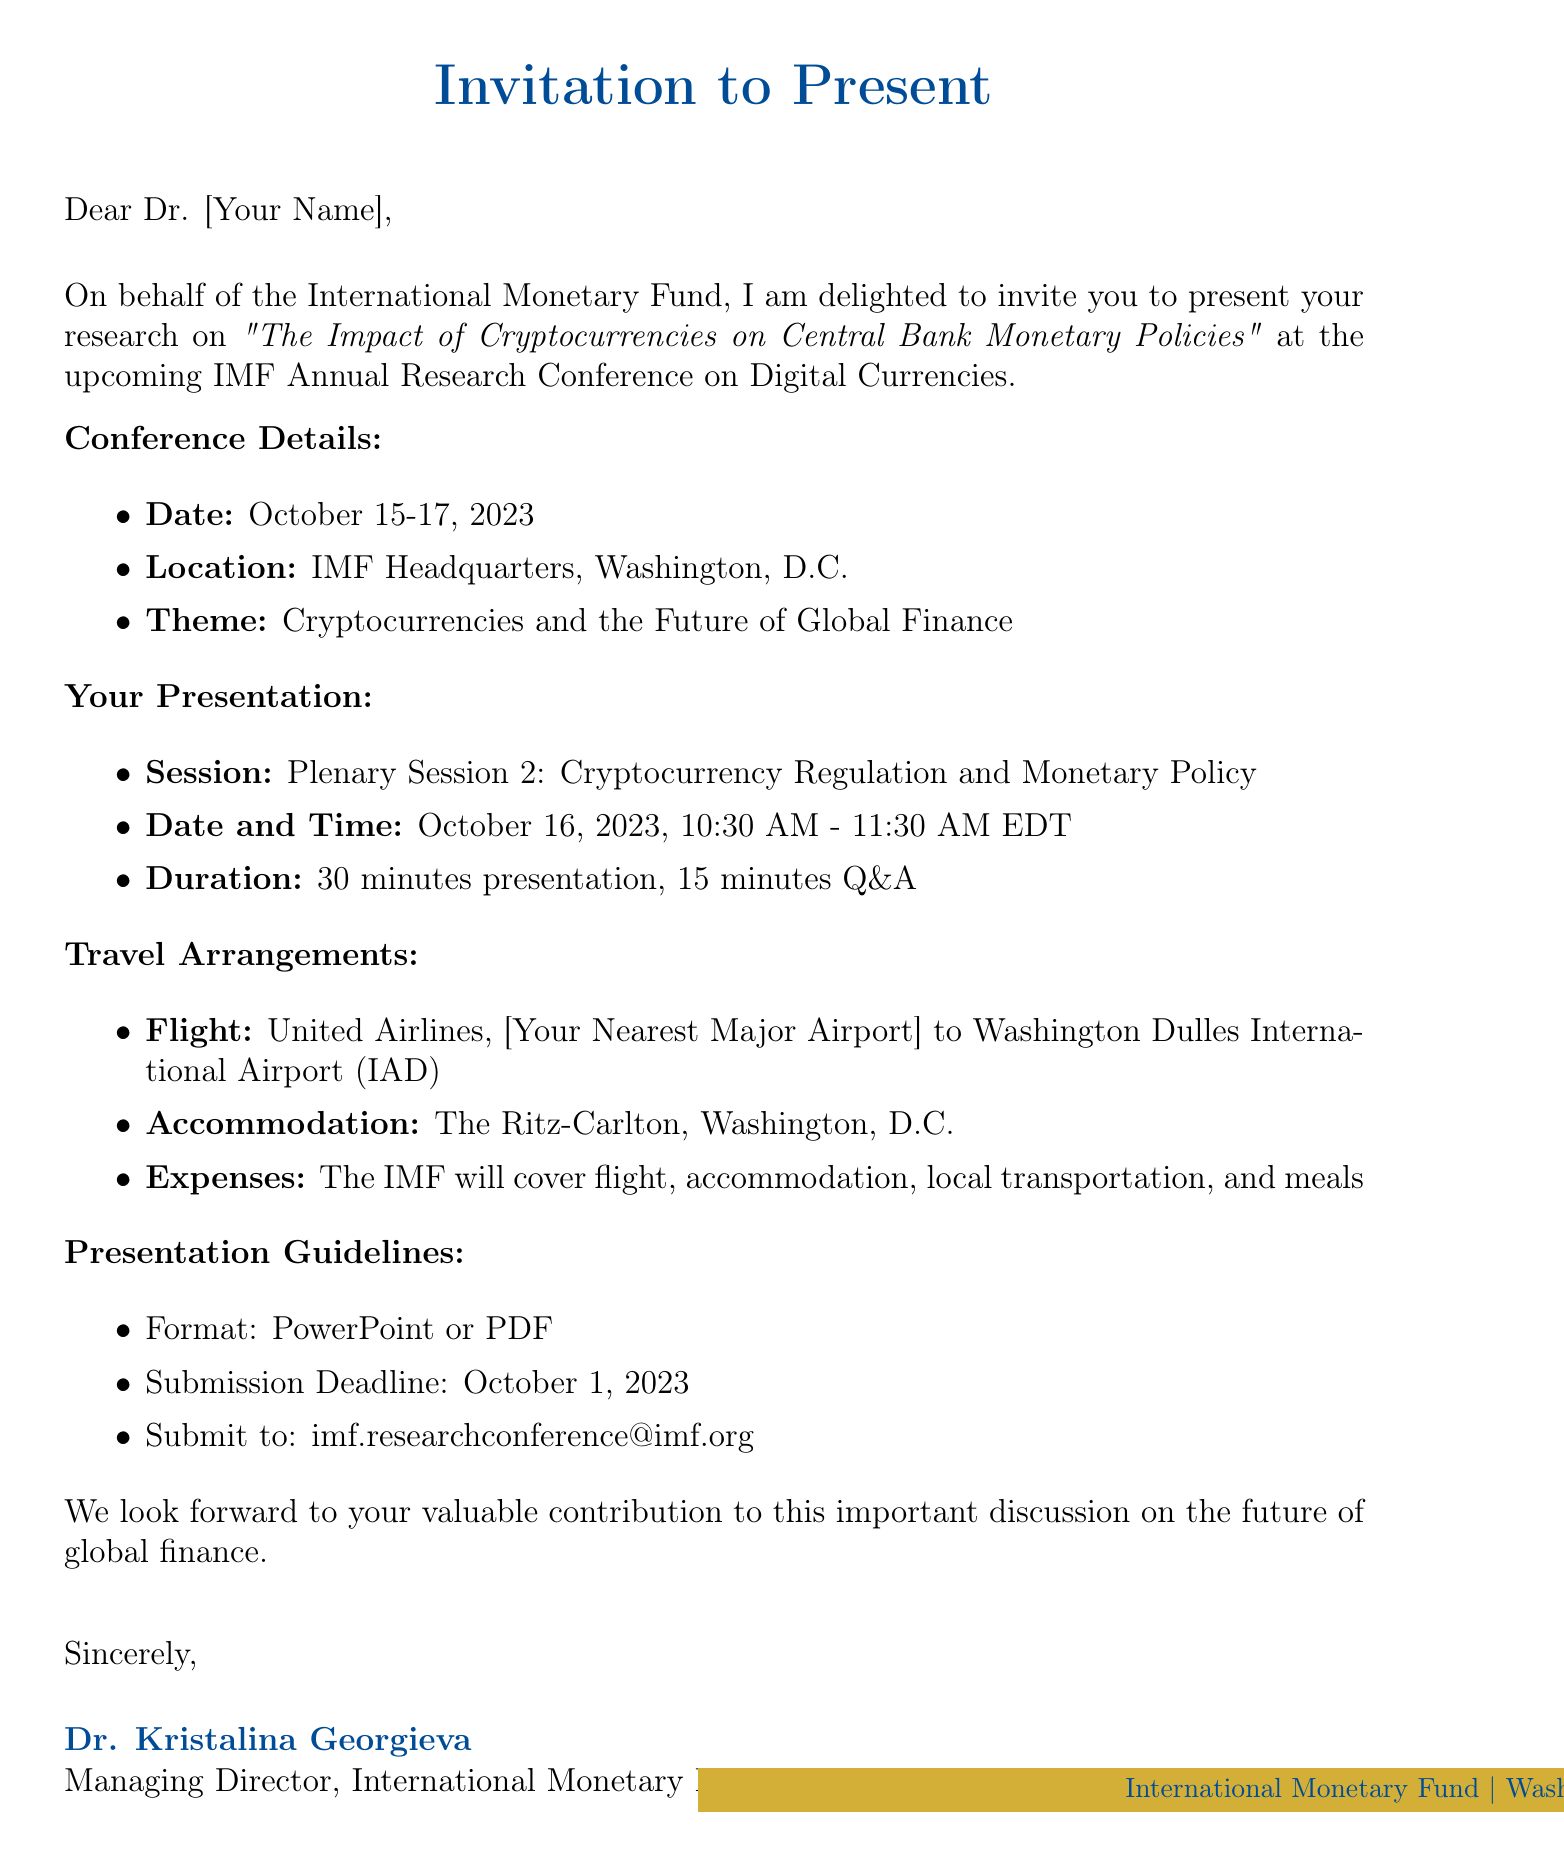What is the name of the conference? The conference is titled "IMF Annual Research Conference on Digital Currencies."
Answer: IMF Annual Research Conference on Digital Currencies Who is sending the invitation? The sender of the invitation is Dr. Kristalina Georgieva, the Managing Director of the IMF.
Answer: Dr. Kristalina Georgieva What is the date of the presentation session? The presentation session is scheduled for October 16, 2023.
Answer: October 16, 2023 What type of format is required for the presentation? The presentation must be in PowerPoint or PDF format.
Answer: PowerPoint or PDF What hotel will the attendees be staying at? The accommodation is arranged at The Ritz-Carlton, Washington, D.C.
Answer: The Ritz-Carlton, Washington, D.C What is the duration of the presentation? The presentation lasts for 30 minutes, followed by 15 minutes for Q&A.
Answer: 30 minutes What is the theme of the conference? The theme of the conference is "Cryptocurrencies and the Future of Global Finance."
Answer: Cryptocurrencies and the Future of Global Finance What is the email address to submit the presentation? The email address for submission of the presentation is imf.researchconference@imf.org.
Answer: imf.researchconference@imf.org What kind of people will be in the audience? The audience will include central bankers, policymakers, academic economists, and financial industry experts.
Answer: Central bankers, policymakers, academic economists, and financial industry experts 